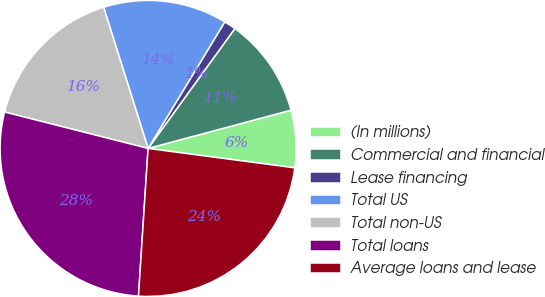Convert chart. <chart><loc_0><loc_0><loc_500><loc_500><pie_chart><fcel>(In millions)<fcel>Commercial and financial<fcel>Lease financing<fcel>Total US<fcel>Total non-US<fcel>Total loans<fcel>Average loans and lease<nl><fcel>6.26%<fcel>10.86%<fcel>1.3%<fcel>13.53%<fcel>16.19%<fcel>27.92%<fcel>23.94%<nl></chart> 